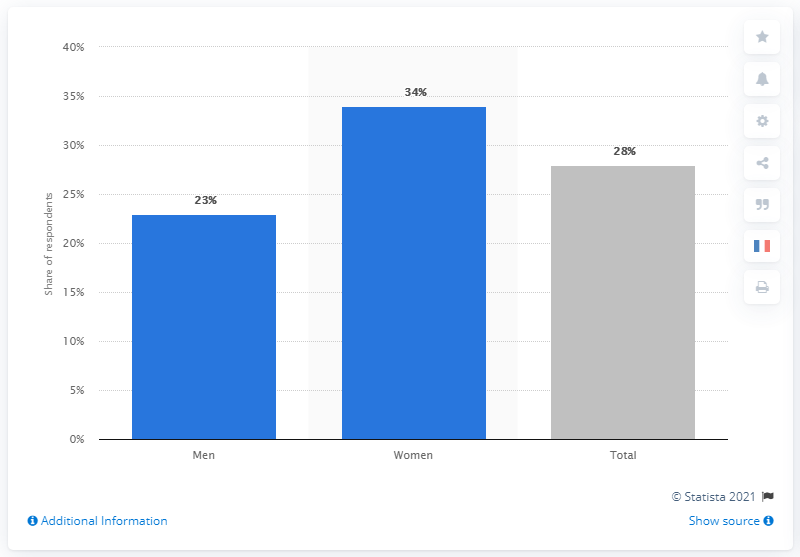What was the percentage of men worried about Coronavirus? According to the bar chart, 23% of men expressed concern about Coronavirus. 